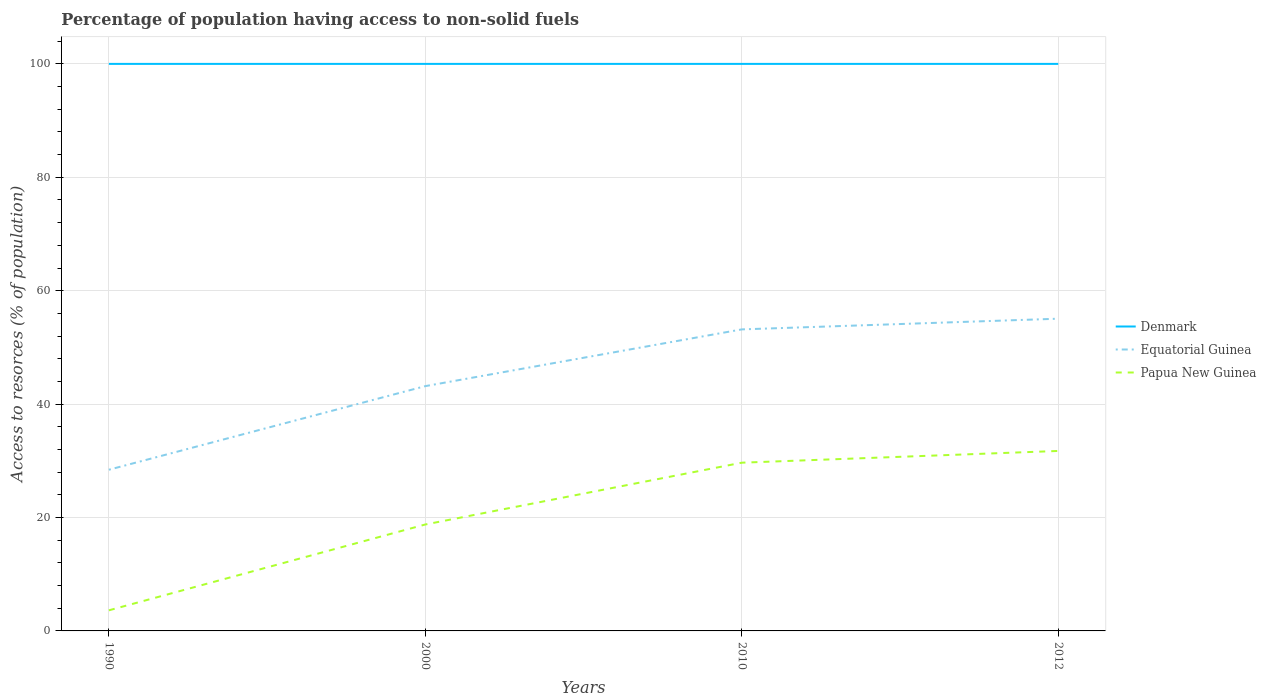Does the line corresponding to Denmark intersect with the line corresponding to Papua New Guinea?
Your response must be concise. No. Is the number of lines equal to the number of legend labels?
Make the answer very short. Yes. Across all years, what is the maximum percentage of population having access to non-solid fuels in Denmark?
Your answer should be compact. 100. In which year was the percentage of population having access to non-solid fuels in Equatorial Guinea maximum?
Offer a terse response. 1990. What is the total percentage of population having access to non-solid fuels in Papua New Guinea in the graph?
Provide a succinct answer. -28.11. What is the difference between the highest and the second highest percentage of population having access to non-solid fuels in Papua New Guinea?
Give a very brief answer. 28.11. How many lines are there?
Offer a terse response. 3. How many years are there in the graph?
Your response must be concise. 4. Does the graph contain grids?
Your answer should be very brief. Yes. How many legend labels are there?
Your response must be concise. 3. How are the legend labels stacked?
Your answer should be very brief. Vertical. What is the title of the graph?
Provide a short and direct response. Percentage of population having access to non-solid fuels. Does "Maldives" appear as one of the legend labels in the graph?
Provide a succinct answer. No. What is the label or title of the Y-axis?
Give a very brief answer. Access to resorces (% of population). What is the Access to resorces (% of population) in Equatorial Guinea in 1990?
Provide a short and direct response. 28.43. What is the Access to resorces (% of population) in Papua New Guinea in 1990?
Give a very brief answer. 3.63. What is the Access to resorces (% of population) in Denmark in 2000?
Your response must be concise. 100. What is the Access to resorces (% of population) in Equatorial Guinea in 2000?
Offer a terse response. 43.17. What is the Access to resorces (% of population) of Papua New Guinea in 2000?
Offer a very short reply. 18.77. What is the Access to resorces (% of population) in Denmark in 2010?
Provide a succinct answer. 100. What is the Access to resorces (% of population) in Equatorial Guinea in 2010?
Provide a succinct answer. 53.18. What is the Access to resorces (% of population) in Papua New Guinea in 2010?
Ensure brevity in your answer.  29.67. What is the Access to resorces (% of population) of Equatorial Guinea in 2012?
Provide a short and direct response. 55.06. What is the Access to resorces (% of population) in Papua New Guinea in 2012?
Offer a terse response. 31.74. Across all years, what is the maximum Access to resorces (% of population) of Denmark?
Provide a succinct answer. 100. Across all years, what is the maximum Access to resorces (% of population) in Equatorial Guinea?
Keep it short and to the point. 55.06. Across all years, what is the maximum Access to resorces (% of population) of Papua New Guinea?
Provide a short and direct response. 31.74. Across all years, what is the minimum Access to resorces (% of population) in Denmark?
Give a very brief answer. 100. Across all years, what is the minimum Access to resorces (% of population) of Equatorial Guinea?
Your response must be concise. 28.43. Across all years, what is the minimum Access to resorces (% of population) in Papua New Guinea?
Offer a very short reply. 3.63. What is the total Access to resorces (% of population) in Denmark in the graph?
Provide a succinct answer. 400. What is the total Access to resorces (% of population) of Equatorial Guinea in the graph?
Offer a very short reply. 179.84. What is the total Access to resorces (% of population) of Papua New Guinea in the graph?
Ensure brevity in your answer.  83.81. What is the difference between the Access to resorces (% of population) in Equatorial Guinea in 1990 and that in 2000?
Your answer should be very brief. -14.75. What is the difference between the Access to resorces (% of population) in Papua New Guinea in 1990 and that in 2000?
Provide a succinct answer. -15.14. What is the difference between the Access to resorces (% of population) in Equatorial Guinea in 1990 and that in 2010?
Your response must be concise. -24.75. What is the difference between the Access to resorces (% of population) in Papua New Guinea in 1990 and that in 2010?
Your response must be concise. -26.04. What is the difference between the Access to resorces (% of population) in Denmark in 1990 and that in 2012?
Make the answer very short. 0. What is the difference between the Access to resorces (% of population) in Equatorial Guinea in 1990 and that in 2012?
Make the answer very short. -26.64. What is the difference between the Access to resorces (% of population) of Papua New Guinea in 1990 and that in 2012?
Provide a succinct answer. -28.11. What is the difference between the Access to resorces (% of population) in Equatorial Guinea in 2000 and that in 2010?
Offer a very short reply. -10.01. What is the difference between the Access to resorces (% of population) in Papua New Guinea in 2000 and that in 2010?
Offer a terse response. -10.9. What is the difference between the Access to resorces (% of population) in Denmark in 2000 and that in 2012?
Make the answer very short. 0. What is the difference between the Access to resorces (% of population) of Equatorial Guinea in 2000 and that in 2012?
Give a very brief answer. -11.89. What is the difference between the Access to resorces (% of population) in Papua New Guinea in 2000 and that in 2012?
Give a very brief answer. -12.97. What is the difference between the Access to resorces (% of population) of Equatorial Guinea in 2010 and that in 2012?
Offer a terse response. -1.89. What is the difference between the Access to resorces (% of population) in Papua New Guinea in 2010 and that in 2012?
Make the answer very short. -2.07. What is the difference between the Access to resorces (% of population) in Denmark in 1990 and the Access to resorces (% of population) in Equatorial Guinea in 2000?
Offer a very short reply. 56.83. What is the difference between the Access to resorces (% of population) in Denmark in 1990 and the Access to resorces (% of population) in Papua New Guinea in 2000?
Ensure brevity in your answer.  81.23. What is the difference between the Access to resorces (% of population) in Equatorial Guinea in 1990 and the Access to resorces (% of population) in Papua New Guinea in 2000?
Your answer should be compact. 9.65. What is the difference between the Access to resorces (% of population) in Denmark in 1990 and the Access to resorces (% of population) in Equatorial Guinea in 2010?
Offer a very short reply. 46.82. What is the difference between the Access to resorces (% of population) in Denmark in 1990 and the Access to resorces (% of population) in Papua New Guinea in 2010?
Ensure brevity in your answer.  70.33. What is the difference between the Access to resorces (% of population) of Equatorial Guinea in 1990 and the Access to resorces (% of population) of Papua New Guinea in 2010?
Your response must be concise. -1.24. What is the difference between the Access to resorces (% of population) in Denmark in 1990 and the Access to resorces (% of population) in Equatorial Guinea in 2012?
Offer a very short reply. 44.94. What is the difference between the Access to resorces (% of population) in Denmark in 1990 and the Access to resorces (% of population) in Papua New Guinea in 2012?
Offer a terse response. 68.26. What is the difference between the Access to resorces (% of population) of Equatorial Guinea in 1990 and the Access to resorces (% of population) of Papua New Guinea in 2012?
Offer a terse response. -3.31. What is the difference between the Access to resorces (% of population) of Denmark in 2000 and the Access to resorces (% of population) of Equatorial Guinea in 2010?
Keep it short and to the point. 46.82. What is the difference between the Access to resorces (% of population) of Denmark in 2000 and the Access to resorces (% of population) of Papua New Guinea in 2010?
Your answer should be very brief. 70.33. What is the difference between the Access to resorces (% of population) in Equatorial Guinea in 2000 and the Access to resorces (% of population) in Papua New Guinea in 2010?
Provide a succinct answer. 13.5. What is the difference between the Access to resorces (% of population) in Denmark in 2000 and the Access to resorces (% of population) in Equatorial Guinea in 2012?
Ensure brevity in your answer.  44.94. What is the difference between the Access to resorces (% of population) in Denmark in 2000 and the Access to resorces (% of population) in Papua New Guinea in 2012?
Your answer should be very brief. 68.26. What is the difference between the Access to resorces (% of population) of Equatorial Guinea in 2000 and the Access to resorces (% of population) of Papua New Guinea in 2012?
Your answer should be compact. 11.43. What is the difference between the Access to resorces (% of population) of Denmark in 2010 and the Access to resorces (% of population) of Equatorial Guinea in 2012?
Ensure brevity in your answer.  44.94. What is the difference between the Access to resorces (% of population) in Denmark in 2010 and the Access to resorces (% of population) in Papua New Guinea in 2012?
Give a very brief answer. 68.26. What is the difference between the Access to resorces (% of population) in Equatorial Guinea in 2010 and the Access to resorces (% of population) in Papua New Guinea in 2012?
Provide a succinct answer. 21.44. What is the average Access to resorces (% of population) in Denmark per year?
Your answer should be very brief. 100. What is the average Access to resorces (% of population) of Equatorial Guinea per year?
Make the answer very short. 44.96. What is the average Access to resorces (% of population) of Papua New Guinea per year?
Offer a terse response. 20.95. In the year 1990, what is the difference between the Access to resorces (% of population) of Denmark and Access to resorces (% of population) of Equatorial Guinea?
Offer a very short reply. 71.57. In the year 1990, what is the difference between the Access to resorces (% of population) of Denmark and Access to resorces (% of population) of Papua New Guinea?
Provide a short and direct response. 96.37. In the year 1990, what is the difference between the Access to resorces (% of population) in Equatorial Guinea and Access to resorces (% of population) in Papua New Guinea?
Provide a short and direct response. 24.8. In the year 2000, what is the difference between the Access to resorces (% of population) in Denmark and Access to resorces (% of population) in Equatorial Guinea?
Provide a succinct answer. 56.83. In the year 2000, what is the difference between the Access to resorces (% of population) of Denmark and Access to resorces (% of population) of Papua New Guinea?
Your answer should be compact. 81.23. In the year 2000, what is the difference between the Access to resorces (% of population) in Equatorial Guinea and Access to resorces (% of population) in Papua New Guinea?
Your answer should be very brief. 24.4. In the year 2010, what is the difference between the Access to resorces (% of population) in Denmark and Access to resorces (% of population) in Equatorial Guinea?
Offer a terse response. 46.82. In the year 2010, what is the difference between the Access to resorces (% of population) of Denmark and Access to resorces (% of population) of Papua New Guinea?
Your answer should be compact. 70.33. In the year 2010, what is the difference between the Access to resorces (% of population) of Equatorial Guinea and Access to resorces (% of population) of Papua New Guinea?
Your response must be concise. 23.51. In the year 2012, what is the difference between the Access to resorces (% of population) of Denmark and Access to resorces (% of population) of Equatorial Guinea?
Give a very brief answer. 44.94. In the year 2012, what is the difference between the Access to resorces (% of population) in Denmark and Access to resorces (% of population) in Papua New Guinea?
Offer a terse response. 68.26. In the year 2012, what is the difference between the Access to resorces (% of population) in Equatorial Guinea and Access to resorces (% of population) in Papua New Guinea?
Offer a terse response. 23.32. What is the ratio of the Access to resorces (% of population) in Denmark in 1990 to that in 2000?
Give a very brief answer. 1. What is the ratio of the Access to resorces (% of population) of Equatorial Guinea in 1990 to that in 2000?
Offer a terse response. 0.66. What is the ratio of the Access to resorces (% of population) of Papua New Guinea in 1990 to that in 2000?
Your answer should be compact. 0.19. What is the ratio of the Access to resorces (% of population) of Equatorial Guinea in 1990 to that in 2010?
Keep it short and to the point. 0.53. What is the ratio of the Access to resorces (% of population) of Papua New Guinea in 1990 to that in 2010?
Give a very brief answer. 0.12. What is the ratio of the Access to resorces (% of population) in Equatorial Guinea in 1990 to that in 2012?
Your response must be concise. 0.52. What is the ratio of the Access to resorces (% of population) in Papua New Guinea in 1990 to that in 2012?
Your answer should be very brief. 0.11. What is the ratio of the Access to resorces (% of population) of Equatorial Guinea in 2000 to that in 2010?
Provide a short and direct response. 0.81. What is the ratio of the Access to resorces (% of population) of Papua New Guinea in 2000 to that in 2010?
Keep it short and to the point. 0.63. What is the ratio of the Access to resorces (% of population) in Denmark in 2000 to that in 2012?
Ensure brevity in your answer.  1. What is the ratio of the Access to resorces (% of population) in Equatorial Guinea in 2000 to that in 2012?
Your answer should be very brief. 0.78. What is the ratio of the Access to resorces (% of population) of Papua New Guinea in 2000 to that in 2012?
Give a very brief answer. 0.59. What is the ratio of the Access to resorces (% of population) in Equatorial Guinea in 2010 to that in 2012?
Make the answer very short. 0.97. What is the ratio of the Access to resorces (% of population) in Papua New Guinea in 2010 to that in 2012?
Provide a short and direct response. 0.93. What is the difference between the highest and the second highest Access to resorces (% of population) of Equatorial Guinea?
Your answer should be very brief. 1.89. What is the difference between the highest and the second highest Access to resorces (% of population) in Papua New Guinea?
Your answer should be compact. 2.07. What is the difference between the highest and the lowest Access to resorces (% of population) in Denmark?
Offer a very short reply. 0. What is the difference between the highest and the lowest Access to resorces (% of population) of Equatorial Guinea?
Make the answer very short. 26.64. What is the difference between the highest and the lowest Access to resorces (% of population) of Papua New Guinea?
Your response must be concise. 28.11. 